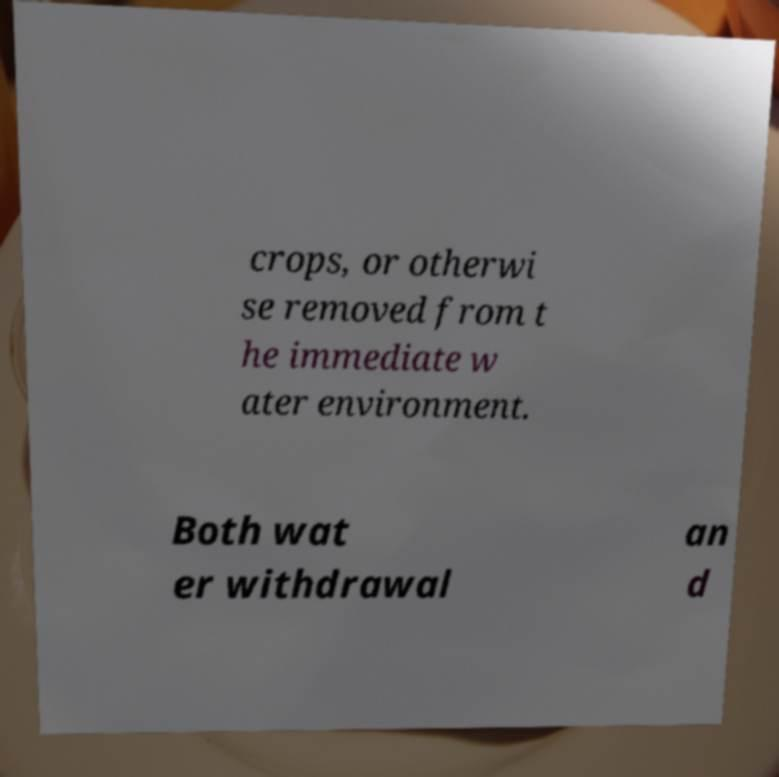Could you assist in decoding the text presented in this image and type it out clearly? crops, or otherwi se removed from t he immediate w ater environment. Both wat er withdrawal an d 